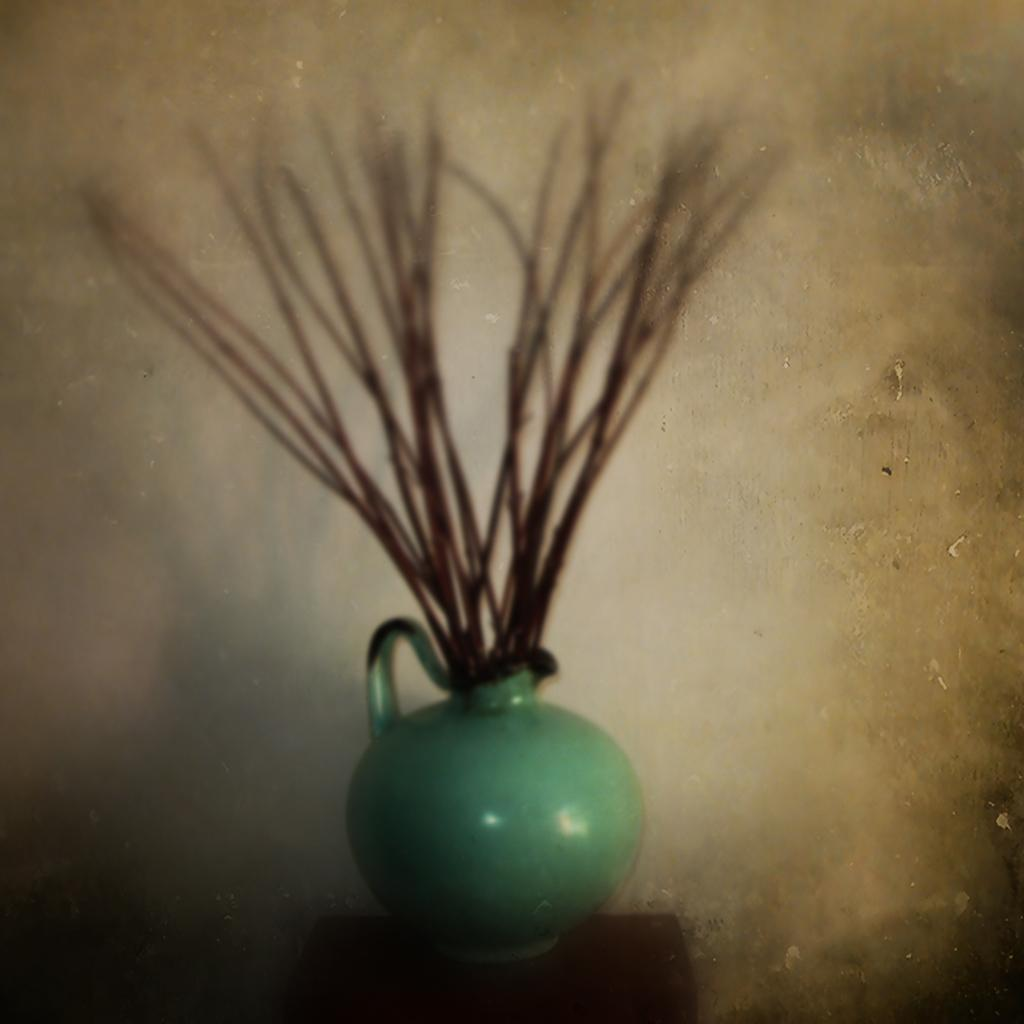What object can be seen in the image? There is a flower vase in the image. What is the color of the flower vase? The flower vase is green in color. What is inside the flower vase? There is a plant in the flower vase. What type of collar can be seen on the plant in the image? There is no collar present on the plant in the image. How does the jelly contribute to the growth of the plant in the image? There is no jelly present in the image, so it cannot contribute to the growth of the plant. 